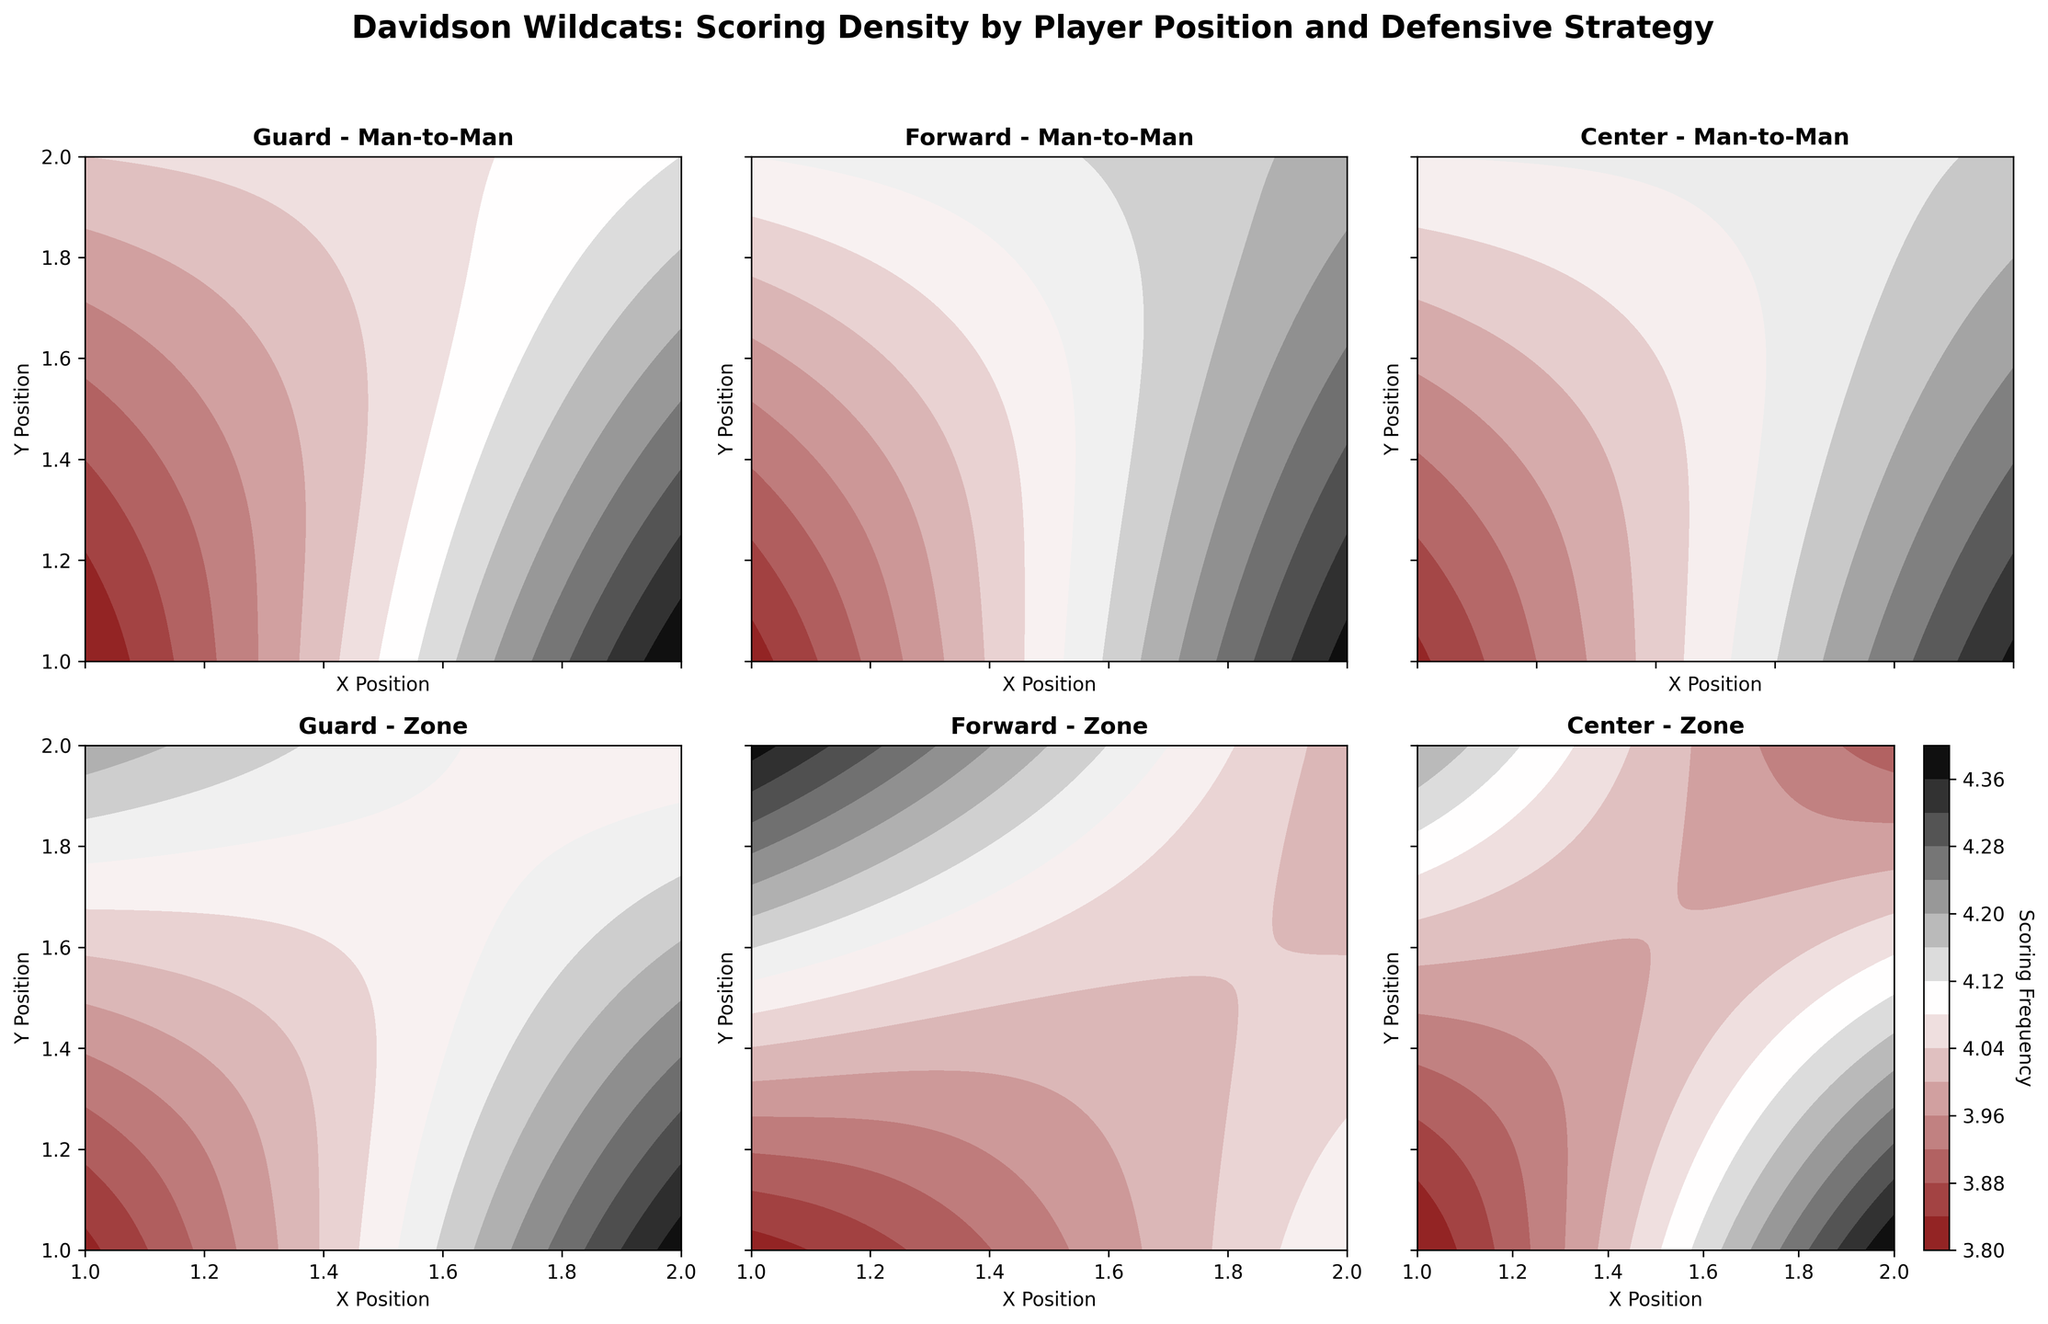What's the title of the figure? Look at the top of the figure where the main title is displayed. The title is "Davidson Wildcats: Scoring Density by Player Position and Defensive Strategy".
Answer: Davidson Wildcats: Scoring Density by Player Position and Defensive Strategy What is the color scheme used in the figure? The figure uses a gradient-based custom color scheme that transitions from dark garnet to white to black, visually emphasizing the scoring density levels.
Answer: Gradient of garnet, white, black How many subplots are there in the figure? Each subplot represents a combination of player position and defensive strategy. There are 2 defensive strategies and 3 player positions, resulting in 6 subplots.
Answer: 6 Which player position has the highest scoring frequency under the Zone defense strategy? By examining the subplots corresponding to Zone defense for each position, the subplot for Centers shows the highest scoring frequency, indicated by darker colors.
Answer: Center For Guards, which defensive strategy leads to a higher scoring frequency at position (2, 1)? Compare the contours at position (2, 1) for both Man-to-Man and Zone strategies for Guards. The scoring frequency is higher for Man-to-Man strategy.
Answer: Man-to-Man What is the general scoring frequency trend for Centers regardless of the defensive strategy? Observing both subplots for Centers, the scoring frequency is generally high at all positions, indicated by darker colors across both defensive strategies.
Answer: Generally high Among Forwards, which defensive strategy yields a more evenly distributed scoring density? Look at the spread and smoothness of the contour levels in both subplots for Forwards. The Zone defense strategy shows a more evenly distributed scoring density.
Answer: Zone What is the scoring frequency for Guards at (1, 2) under Zone strategy? Refer to the subplot for Guards under Zone defense and find the contour line or color value at position (1, 2). The frequency is 3.4.
Answer: 3.4 